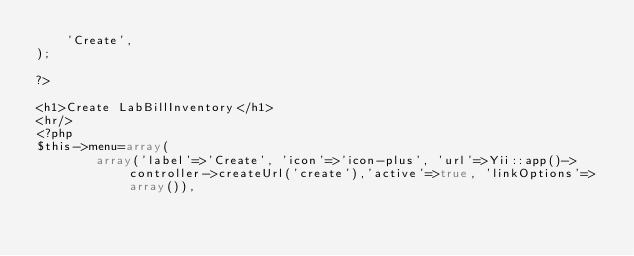<code> <loc_0><loc_0><loc_500><loc_500><_PHP_>	'Create',
);

?>

<h1>Create LabBillInventory</h1>
<hr/>
<?php 
$this->menu=array(
		array('label'=>'Create', 'icon'=>'icon-plus', 'url'=>Yii::app()->controller->createUrl('create'),'active'=>true, 'linkOptions'=>array()),</code> 